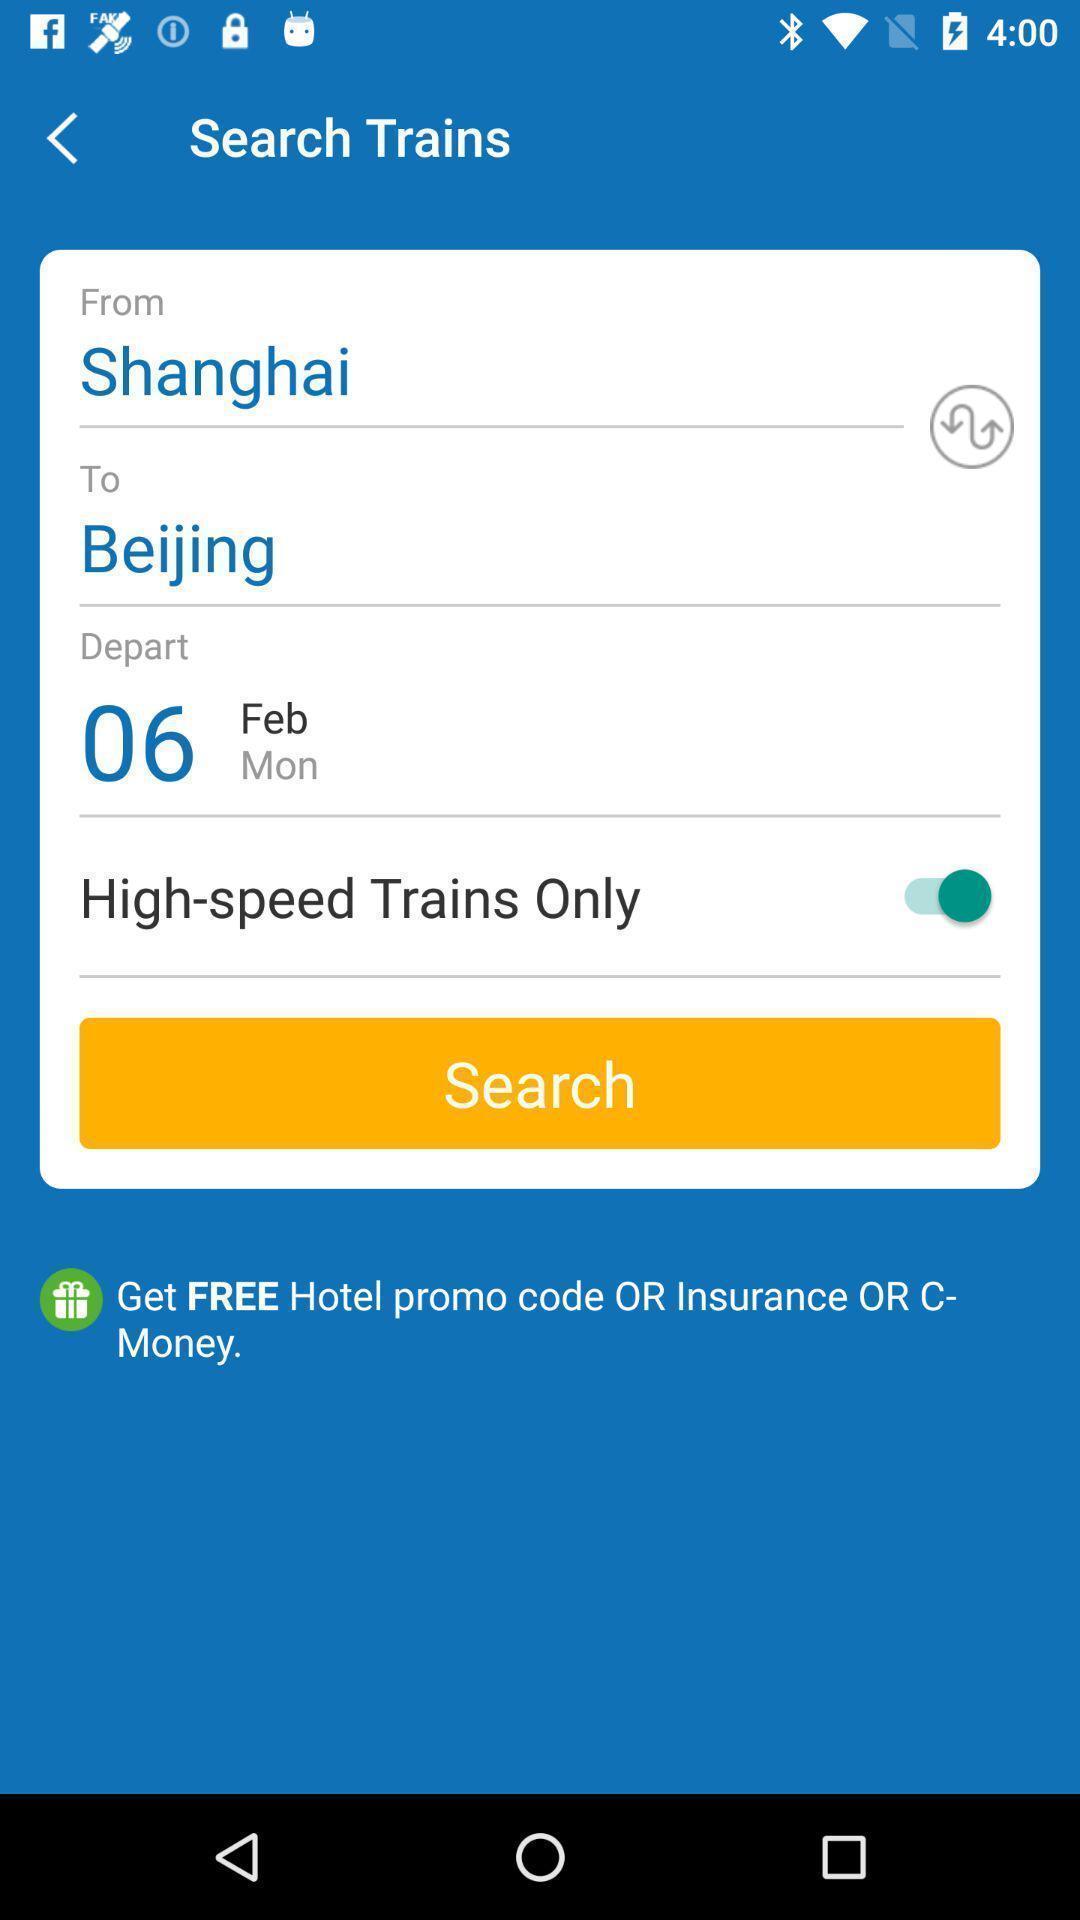Provide a description of this screenshot. Search page in a train booking app. 